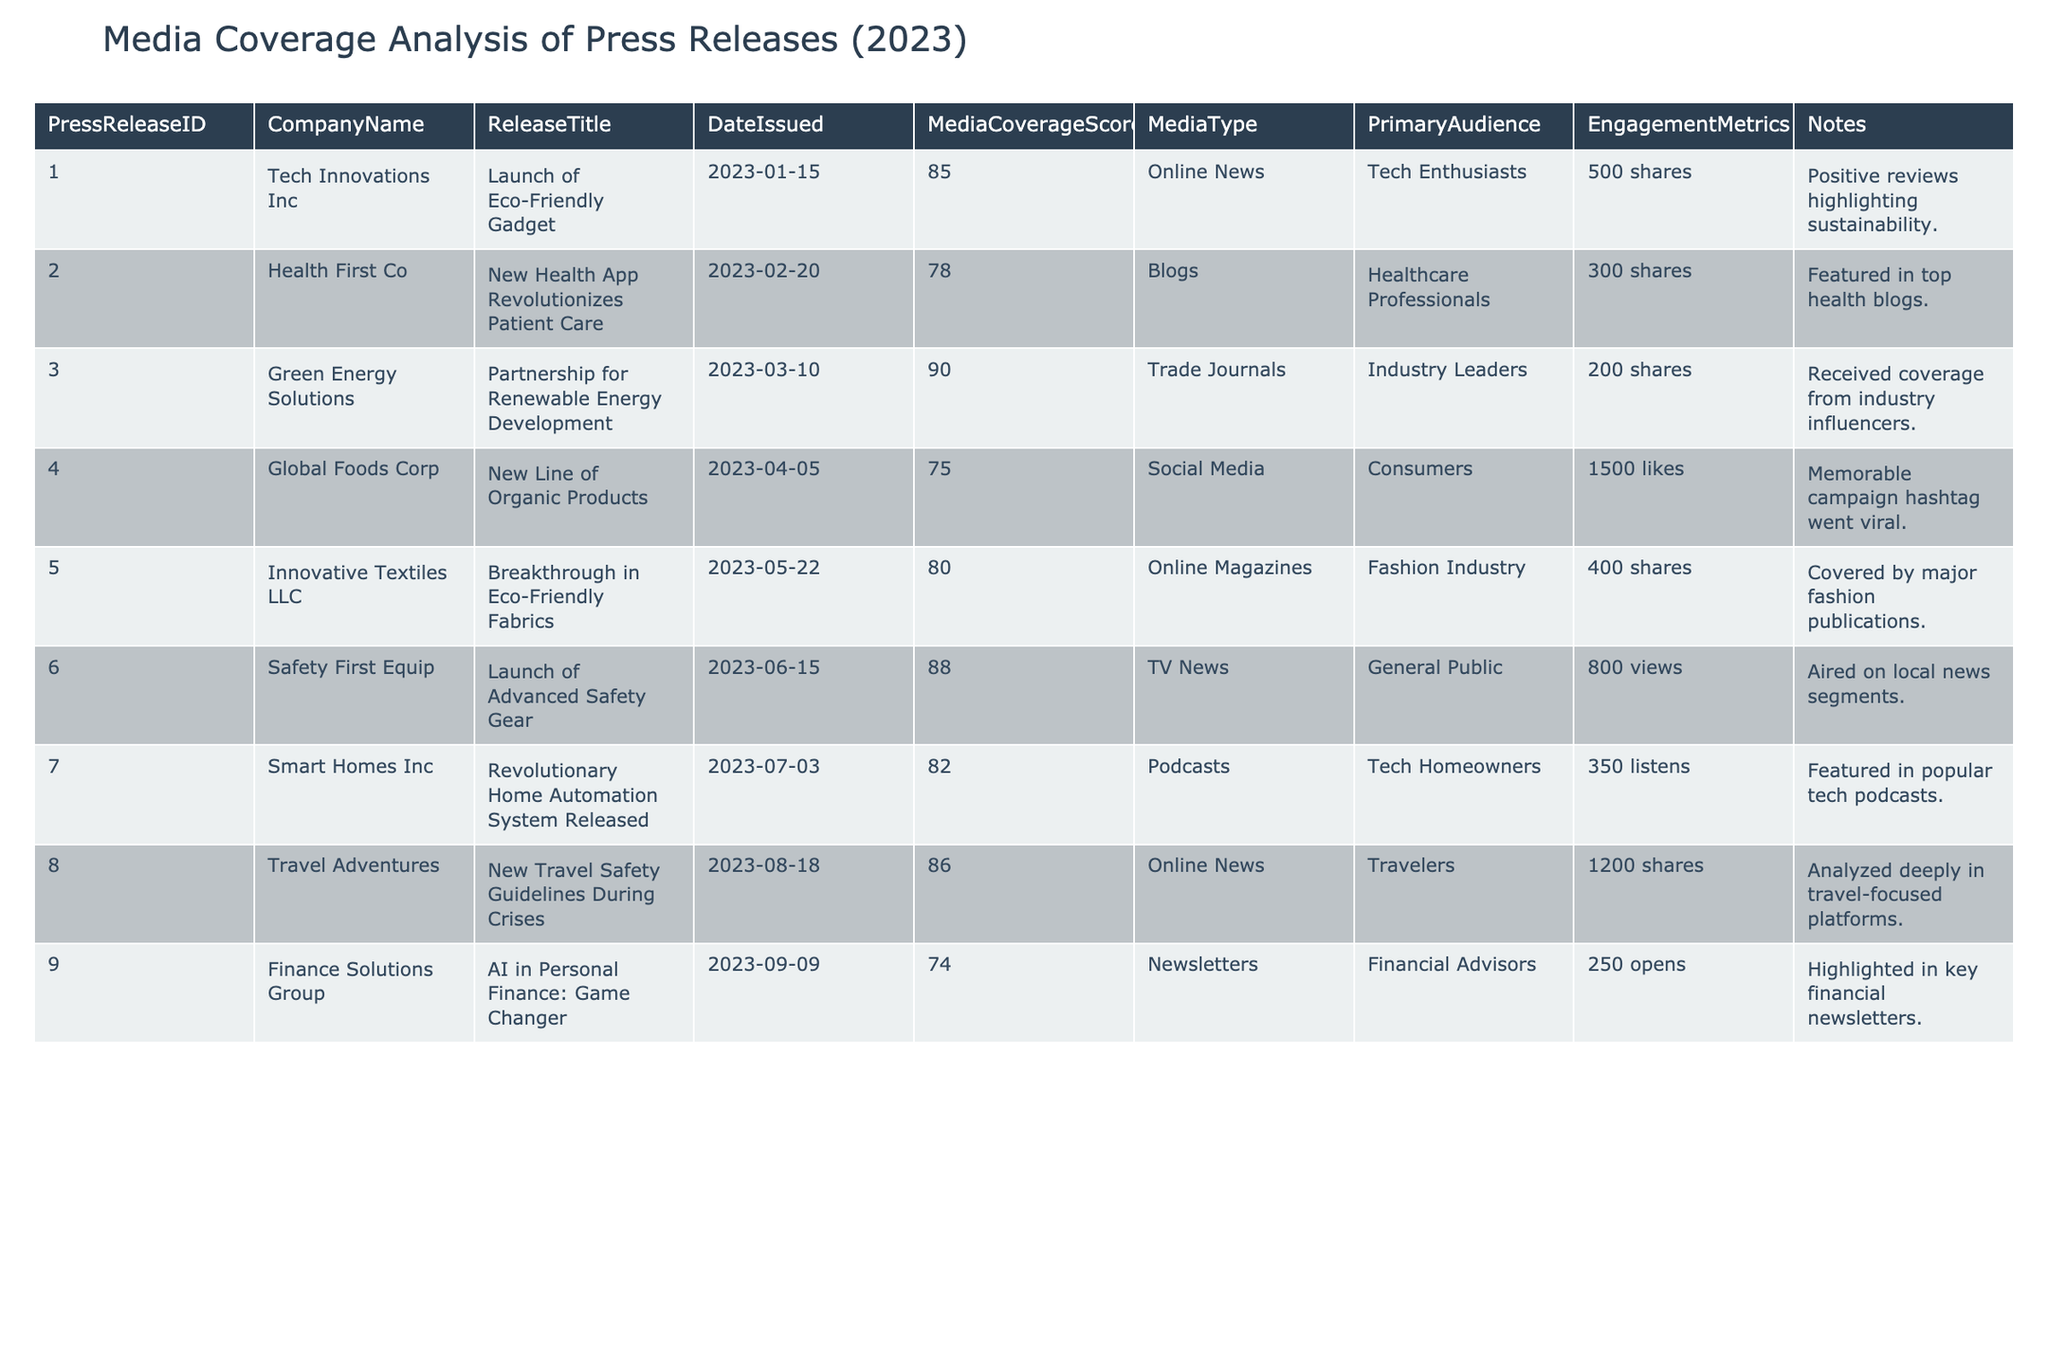What is the Media Coverage Score for the press release from Tech Innovations Inc? The Media Coverage Score for Tech Innovations Inc is found in the second column of the row corresponding to the first press release. It is given directly as 85.
Answer: 85 Which company had the highest Media Coverage Score in 2023? To find the highest Media Coverage Score, we need to look through the Media Coverage Score column and identify the maximum score. The highest score is 90, attributed to Green Energy Solutions.
Answer: Green Energy Solutions How many shares did the press release about the Eco-Friendly Gadget receive? The engagement metrics for the Eco-Friendly Gadget, released by Tech Innovations Inc, are listed in the Engagement Metrics column for that specific press release. It states there were 500 shares.
Answer: 500 shares What is the average Media Coverage Score for the press releases issued in 2023? To calculate the average Media Coverage Score, sum up all the scores: 85 + 78 + 90 + 75 + 80 + 88 + 82 + 86 + 74 =  758. There are 9 press releases, so the average is 758/9, which is approximately 84.2.
Answer: 84.2 Did Health First Co receive more shares than Finance Solutions Group with their press releases? Health First Co had 300 shares as engagement metrics for their press release. Finance Solutions Group had 250 opens as engagement metrics. Since 300 is greater than 250, the answer is yes.
Answer: Yes Which media type had the highest audience engagement, and how many engagement metrics did it have? Looking at the Engagement Metrics column, Global Foods Corp in the Social Media category had the highest engagement with 1500 likes. This indicates the highest audience engagement among all press releases.
Answer: Social Media; 1500 likes Among the press releases, which one targeted Industry Leaders as the primary audience? By reviewing the Primary Audience column, the press release by Green Energy Solutions, titled "Partnership for Renewable Energy Development," targeted Industry Leaders.
Answer: Green Energy Solutions How many press releases were issued in the first half of 2023? The press releases issued between January 1 and June 30, 2023, include: 1) Launch of Eco-Friendly Gadget, 2) New Health App Revolutionizes Patient Care, 3) Partnership for Renewable Energy Development, 4) New Line of Organic Products, and 5) Launch of Advanced Safety Gear. There are 5 press releases in total for this period.
Answer: 5 Which release had the least number of shares and what was the score? The release with the least shares can be found by checking the Engagement Metrics column. Finance Solutions Group had 250 opens, which is the lowest engagement. Its Media Coverage Score is 74.
Answer: Finance Solutions Group; 74 